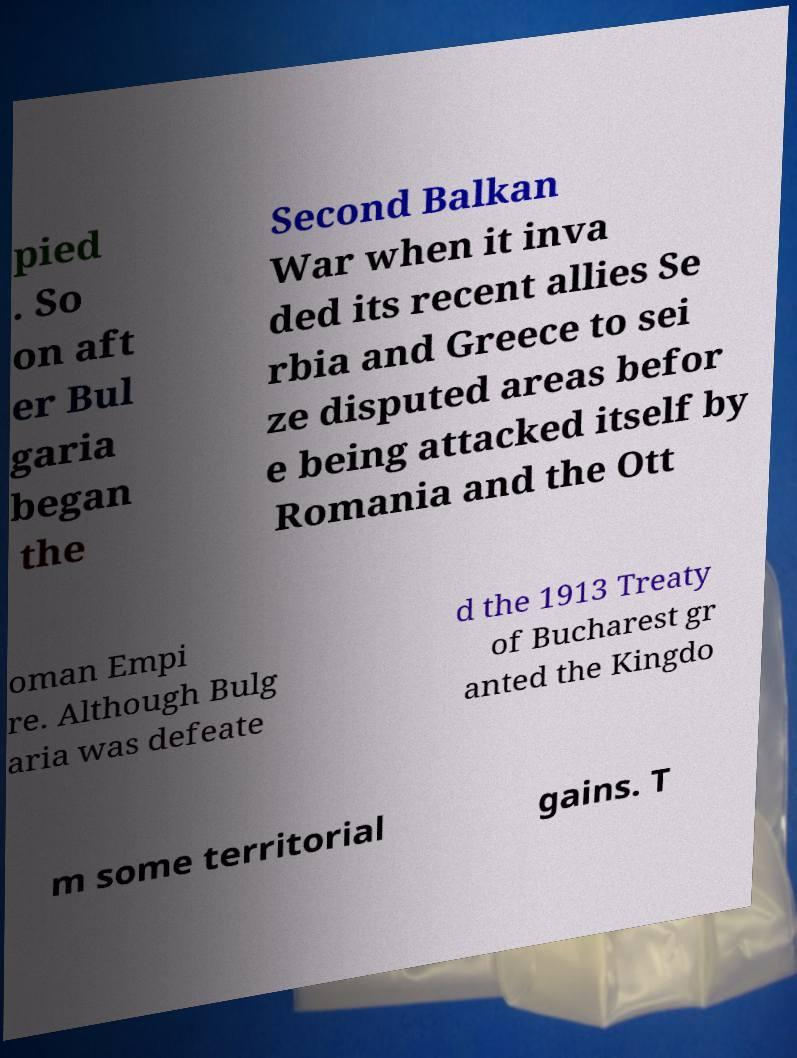I need the written content from this picture converted into text. Can you do that? pied . So on aft er Bul garia began the Second Balkan War when it inva ded its recent allies Se rbia and Greece to sei ze disputed areas befor e being attacked itself by Romania and the Ott oman Empi re. Although Bulg aria was defeate d the 1913 Treaty of Bucharest gr anted the Kingdo m some territorial gains. T 